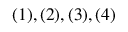Convert formula to latex. <formula><loc_0><loc_0><loc_500><loc_500>( 1 ) , ( 2 ) , ( 3 ) , ( 4 )</formula> 